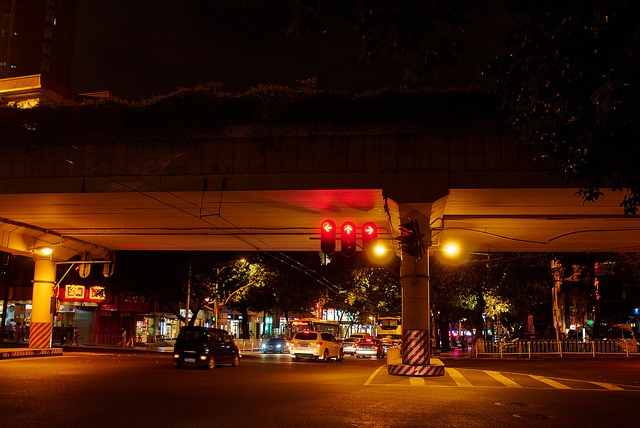Describe the objects in this image and their specific colors. I can see car in black, maroon, and brown tones, car in black, red, and maroon tones, traffic light in black, red, maroon, and brown tones, traffic light in black, red, and maroon tones, and traffic light in black, red, and brown tones in this image. 